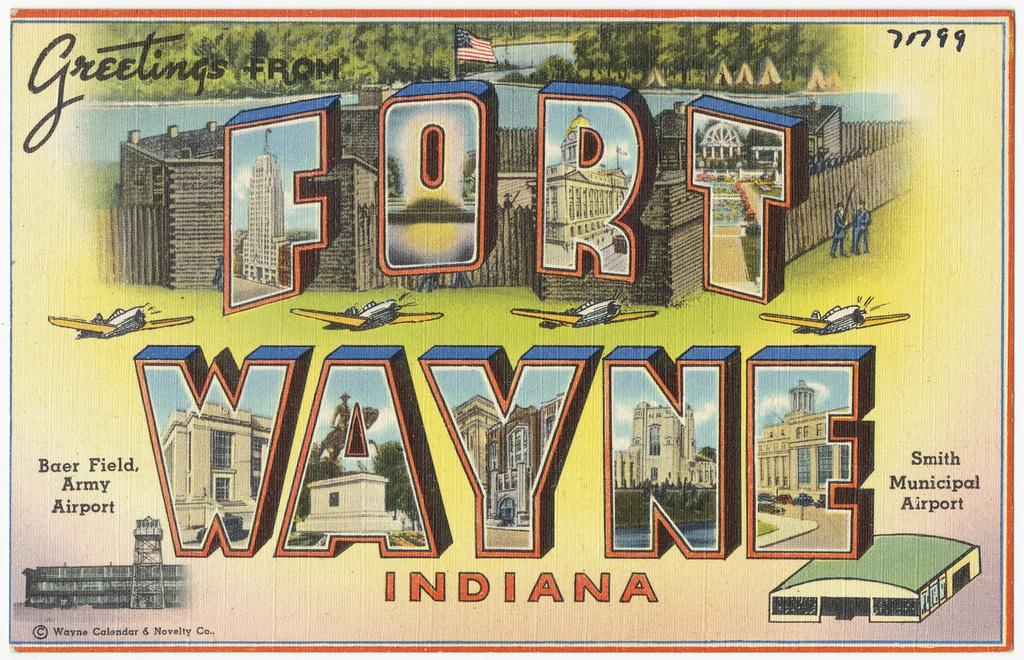<image>
Offer a succinct explanation of the picture presented. The old postcard is from Fort Wayne Indiana. 